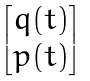Convert formula to latex. <formula><loc_0><loc_0><loc_500><loc_500>\begin{bmatrix} q ( t ) \\ p ( t ) \end{bmatrix}</formula> 